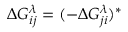Convert formula to latex. <formula><loc_0><loc_0><loc_500><loc_500>\Delta G _ { i j } ^ { \lambda } = ( - \Delta G _ { j i } ^ { \lambda } ) ^ { * }</formula> 